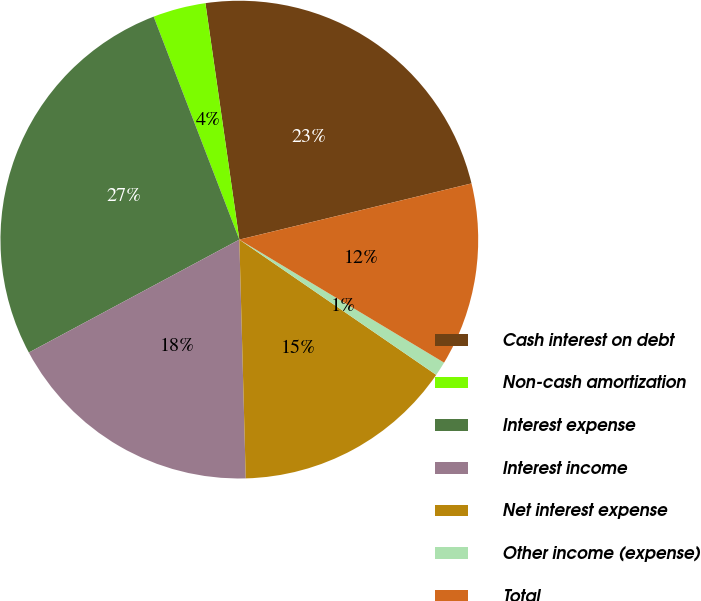<chart> <loc_0><loc_0><loc_500><loc_500><pie_chart><fcel>Cash interest on debt<fcel>Non-cash amortization<fcel>Interest expense<fcel>Interest income<fcel>Net interest expense<fcel>Other income (expense)<fcel>Total<nl><fcel>23.49%<fcel>3.57%<fcel>27.0%<fcel>17.59%<fcel>14.99%<fcel>0.97%<fcel>12.39%<nl></chart> 